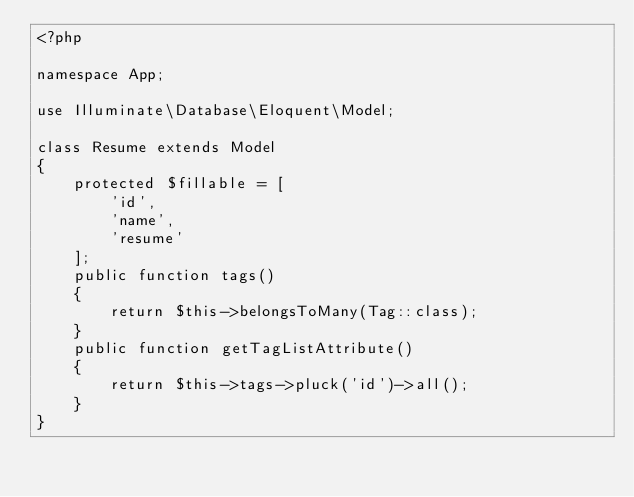Convert code to text. <code><loc_0><loc_0><loc_500><loc_500><_PHP_><?php

namespace App;

use Illuminate\Database\Eloquent\Model;

class Resume extends Model
{
    protected $fillable = [
        'id',
        'name',
        'resume'
    ];
    public function tags()
    {
        return $this->belongsToMany(Tag::class);
    }
    public function getTagListAttribute()
    {
        return $this->tags->pluck('id')->all();
    }
}
</code> 